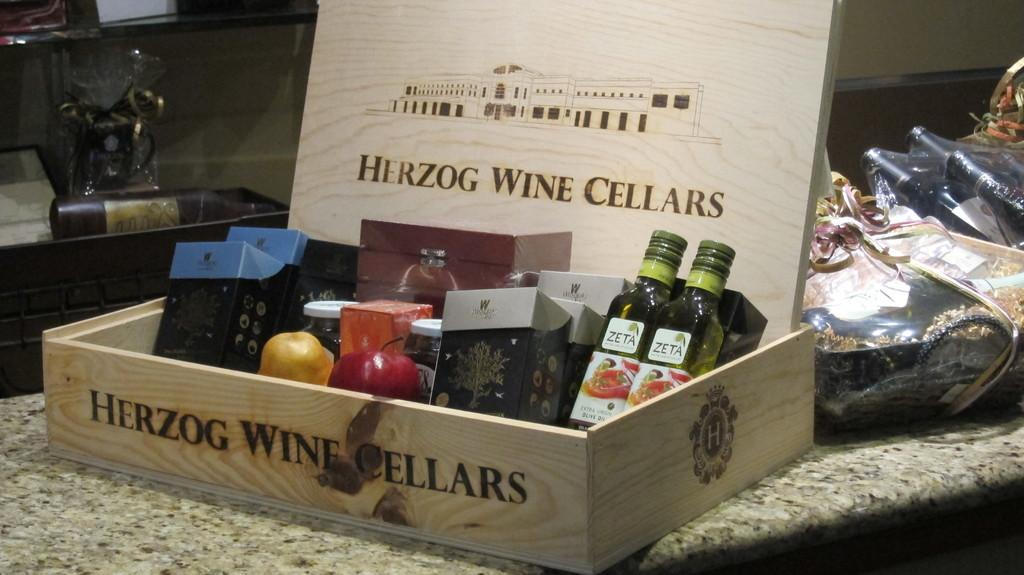What object is present in the image that is typically used for storage? There is a box in the image. What device can be seen in the image that is used for sewing? There is a sewing machine in the image. What items are stored inside the box in the image? There are bottles and fruits in the box. How many oranges are tied in a knot in the image? There are no oranges or knots present in the image. 